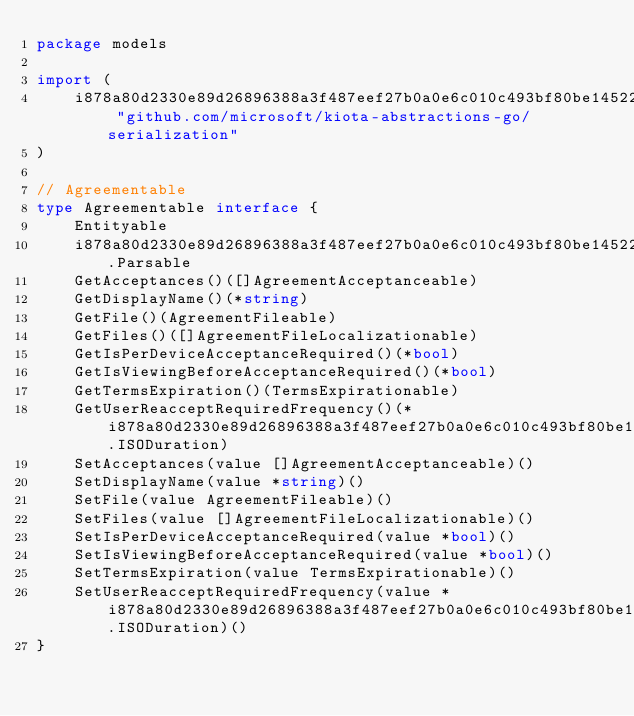<code> <loc_0><loc_0><loc_500><loc_500><_Go_>package models

import (
    i878a80d2330e89d26896388a3f487eef27b0a0e6c010c493bf80be1452208f91 "github.com/microsoft/kiota-abstractions-go/serialization"
)

// Agreementable 
type Agreementable interface {
    Entityable
    i878a80d2330e89d26896388a3f487eef27b0a0e6c010c493bf80be1452208f91.Parsable
    GetAcceptances()([]AgreementAcceptanceable)
    GetDisplayName()(*string)
    GetFile()(AgreementFileable)
    GetFiles()([]AgreementFileLocalizationable)
    GetIsPerDeviceAcceptanceRequired()(*bool)
    GetIsViewingBeforeAcceptanceRequired()(*bool)
    GetTermsExpiration()(TermsExpirationable)
    GetUserReacceptRequiredFrequency()(*i878a80d2330e89d26896388a3f487eef27b0a0e6c010c493bf80be1452208f91.ISODuration)
    SetAcceptances(value []AgreementAcceptanceable)()
    SetDisplayName(value *string)()
    SetFile(value AgreementFileable)()
    SetFiles(value []AgreementFileLocalizationable)()
    SetIsPerDeviceAcceptanceRequired(value *bool)()
    SetIsViewingBeforeAcceptanceRequired(value *bool)()
    SetTermsExpiration(value TermsExpirationable)()
    SetUserReacceptRequiredFrequency(value *i878a80d2330e89d26896388a3f487eef27b0a0e6c010c493bf80be1452208f91.ISODuration)()
}
</code> 